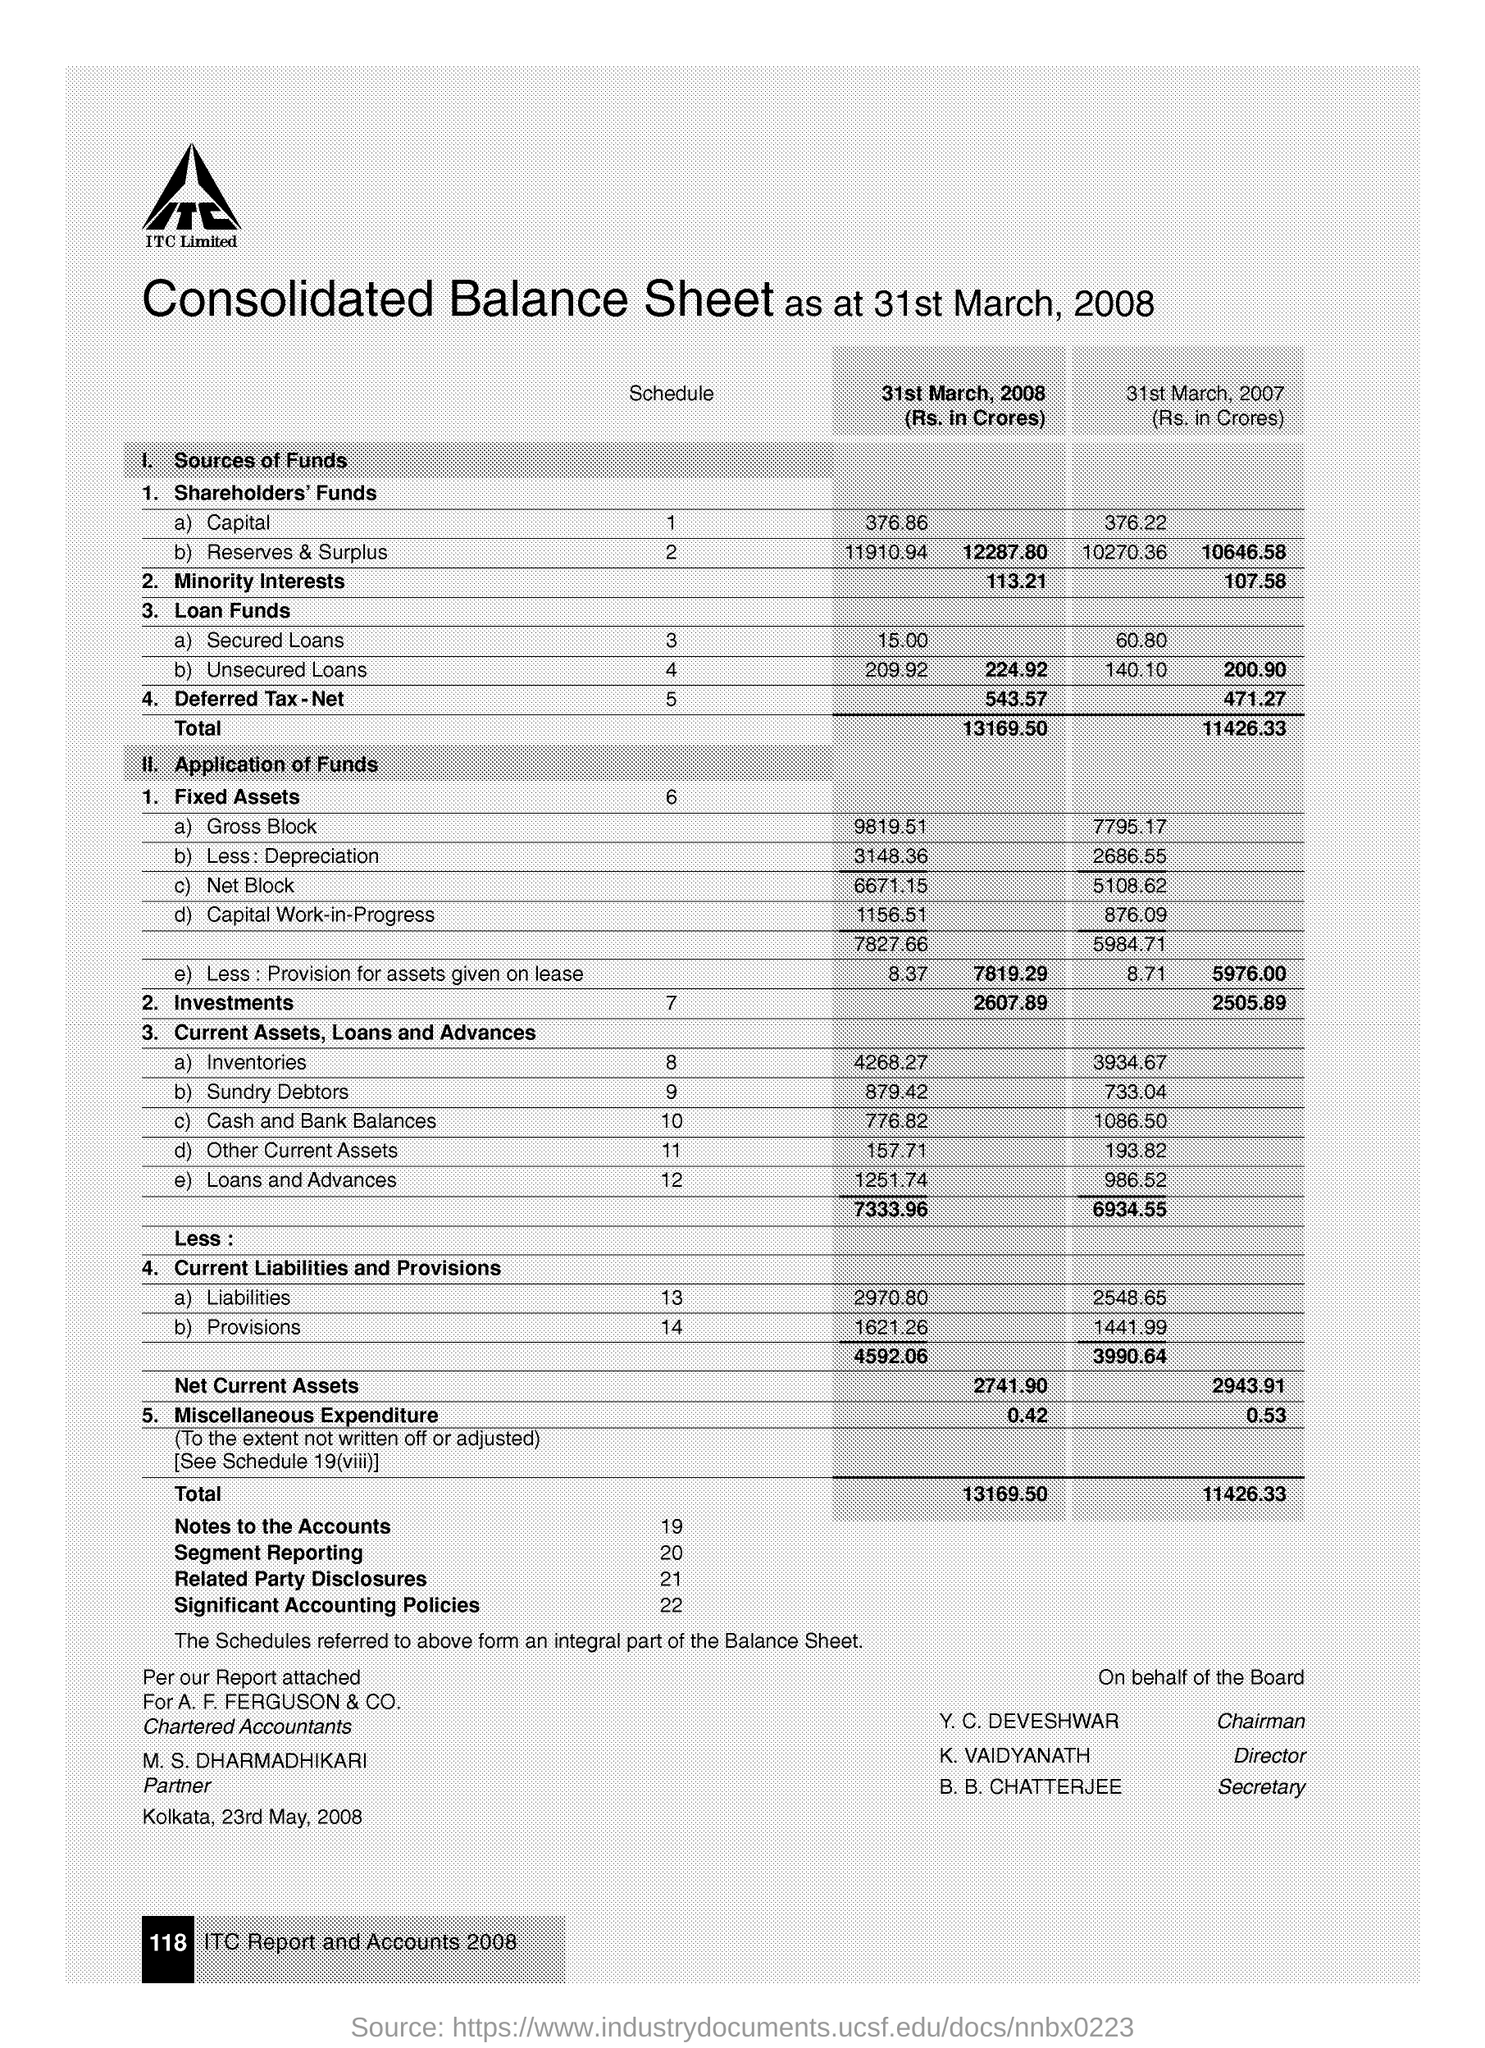Specify some key components in this picture. The document is dated on May 23, 2008. Y. C. Deveshwar is the Chairman. The document indicates that the place name is Kolkata. On March 31, 2007, the total investments were 2505.89. The Director is K. Vaidyanath. 